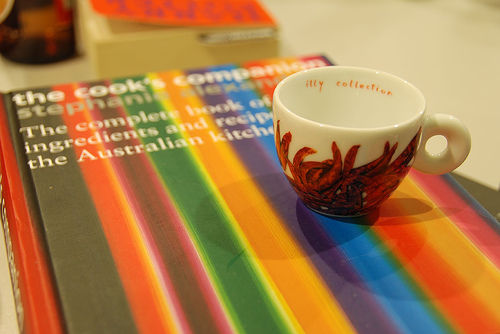<image>
Can you confirm if the book is in front of the cup? No. The book is not in front of the cup. The spatial positioning shows a different relationship between these objects. 